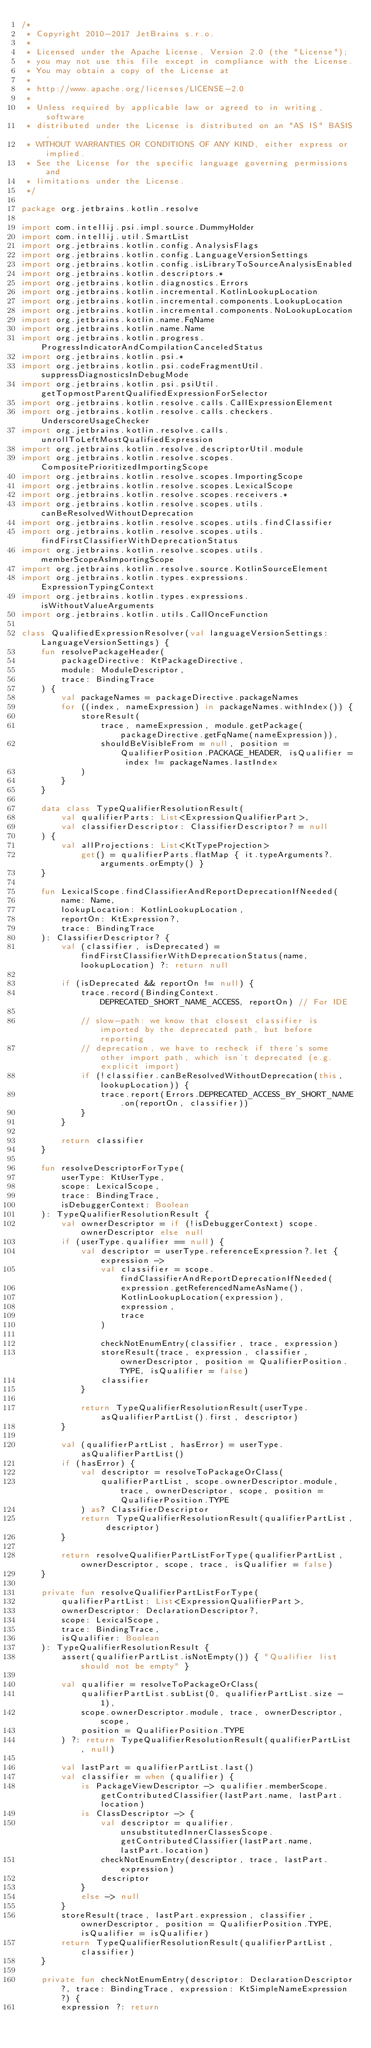<code> <loc_0><loc_0><loc_500><loc_500><_Kotlin_>/*
 * Copyright 2010-2017 JetBrains s.r.o.
 *
 * Licensed under the Apache License, Version 2.0 (the "License");
 * you may not use this file except in compliance with the License.
 * You may obtain a copy of the License at
 *
 * http://www.apache.org/licenses/LICENSE-2.0
 *
 * Unless required by applicable law or agreed to in writing, software
 * distributed under the License is distributed on an "AS IS" BASIS,
 * WITHOUT WARRANTIES OR CONDITIONS OF ANY KIND, either express or implied.
 * See the License for the specific language governing permissions and
 * limitations under the License.
 */

package org.jetbrains.kotlin.resolve

import com.intellij.psi.impl.source.DummyHolder
import com.intellij.util.SmartList
import org.jetbrains.kotlin.config.AnalysisFlags
import org.jetbrains.kotlin.config.LanguageVersionSettings
import org.jetbrains.kotlin.config.isLibraryToSourceAnalysisEnabled
import org.jetbrains.kotlin.descriptors.*
import org.jetbrains.kotlin.diagnostics.Errors
import org.jetbrains.kotlin.incremental.KotlinLookupLocation
import org.jetbrains.kotlin.incremental.components.LookupLocation
import org.jetbrains.kotlin.incremental.components.NoLookupLocation
import org.jetbrains.kotlin.name.FqName
import org.jetbrains.kotlin.name.Name
import org.jetbrains.kotlin.progress.ProgressIndicatorAndCompilationCanceledStatus
import org.jetbrains.kotlin.psi.*
import org.jetbrains.kotlin.psi.codeFragmentUtil.suppressDiagnosticsInDebugMode
import org.jetbrains.kotlin.psi.psiUtil.getTopmostParentQualifiedExpressionForSelector
import org.jetbrains.kotlin.resolve.calls.CallExpressionElement
import org.jetbrains.kotlin.resolve.calls.checkers.UnderscoreUsageChecker
import org.jetbrains.kotlin.resolve.calls.unrollToLeftMostQualifiedExpression
import org.jetbrains.kotlin.resolve.descriptorUtil.module
import org.jetbrains.kotlin.resolve.scopes.CompositePrioritizedImportingScope
import org.jetbrains.kotlin.resolve.scopes.ImportingScope
import org.jetbrains.kotlin.resolve.scopes.LexicalScope
import org.jetbrains.kotlin.resolve.scopes.receivers.*
import org.jetbrains.kotlin.resolve.scopes.utils.canBeResolvedWithoutDeprecation
import org.jetbrains.kotlin.resolve.scopes.utils.findClassifier
import org.jetbrains.kotlin.resolve.scopes.utils.findFirstClassifierWithDeprecationStatus
import org.jetbrains.kotlin.resolve.scopes.utils.memberScopeAsImportingScope
import org.jetbrains.kotlin.resolve.source.KotlinSourceElement
import org.jetbrains.kotlin.types.expressions.ExpressionTypingContext
import org.jetbrains.kotlin.types.expressions.isWithoutValueArguments
import org.jetbrains.kotlin.utils.CallOnceFunction

class QualifiedExpressionResolver(val languageVersionSettings: LanguageVersionSettings) {
    fun resolvePackageHeader(
        packageDirective: KtPackageDirective,
        module: ModuleDescriptor,
        trace: BindingTrace
    ) {
        val packageNames = packageDirective.packageNames
        for ((index, nameExpression) in packageNames.withIndex()) {
            storeResult(
                trace, nameExpression, module.getPackage(packageDirective.getFqName(nameExpression)),
                shouldBeVisibleFrom = null, position = QualifierPosition.PACKAGE_HEADER, isQualifier = index != packageNames.lastIndex
            )
        }
    }

    data class TypeQualifierResolutionResult(
        val qualifierParts: List<ExpressionQualifierPart>,
        val classifierDescriptor: ClassifierDescriptor? = null
    ) {
        val allProjections: List<KtTypeProjection>
            get() = qualifierParts.flatMap { it.typeArguments?.arguments.orEmpty() }
    }

    fun LexicalScope.findClassifierAndReportDeprecationIfNeeded(
        name: Name,
        lookupLocation: KotlinLookupLocation,
        reportOn: KtExpression?,
        trace: BindingTrace
    ): ClassifierDescriptor? {
        val (classifier, isDeprecated) = findFirstClassifierWithDeprecationStatus(name, lookupLocation) ?: return null

        if (isDeprecated && reportOn != null) {
            trace.record(BindingContext.DEPRECATED_SHORT_NAME_ACCESS, reportOn) // For IDE

            // slow-path: we know that closest classifier is imported by the deprecated path, but before reporting
            // deprecation, we have to recheck if there's some other import path, which isn't deprecated (e.g. explicit import)
            if (!classifier.canBeResolvedWithoutDeprecation(this, lookupLocation)) {
                trace.report(Errors.DEPRECATED_ACCESS_BY_SHORT_NAME.on(reportOn, classifier))
            }
        }

        return classifier
    }

    fun resolveDescriptorForType(
        userType: KtUserType,
        scope: LexicalScope,
        trace: BindingTrace,
        isDebuggerContext: Boolean
    ): TypeQualifierResolutionResult {
        val ownerDescriptor = if (!isDebuggerContext) scope.ownerDescriptor else null
        if (userType.qualifier == null) {
            val descriptor = userType.referenceExpression?.let { expression ->
                val classifier = scope.findClassifierAndReportDeprecationIfNeeded(
                    expression.getReferencedNameAsName(),
                    KotlinLookupLocation(expression),
                    expression,
                    trace
                )

                checkNotEnumEntry(classifier, trace, expression)
                storeResult(trace, expression, classifier, ownerDescriptor, position = QualifierPosition.TYPE, isQualifier = false)
                classifier
            }

            return TypeQualifierResolutionResult(userType.asQualifierPartList().first, descriptor)
        }

        val (qualifierPartList, hasError) = userType.asQualifierPartList()
        if (hasError) {
            val descriptor = resolveToPackageOrClass(
                qualifierPartList, scope.ownerDescriptor.module, trace, ownerDescriptor, scope, position = QualifierPosition.TYPE
            ) as? ClassifierDescriptor
            return TypeQualifierResolutionResult(qualifierPartList, descriptor)
        }

        return resolveQualifierPartListForType(qualifierPartList, ownerDescriptor, scope, trace, isQualifier = false)
    }

    private fun resolveQualifierPartListForType(
        qualifierPartList: List<ExpressionQualifierPart>,
        ownerDescriptor: DeclarationDescriptor?,
        scope: LexicalScope,
        trace: BindingTrace,
        isQualifier: Boolean
    ): TypeQualifierResolutionResult {
        assert(qualifierPartList.isNotEmpty()) { "Qualifier list should not be empty" }

        val qualifier = resolveToPackageOrClass(
            qualifierPartList.subList(0, qualifierPartList.size - 1),
            scope.ownerDescriptor.module, trace, ownerDescriptor, scope,
            position = QualifierPosition.TYPE
        ) ?: return TypeQualifierResolutionResult(qualifierPartList, null)

        val lastPart = qualifierPartList.last()
        val classifier = when (qualifier) {
            is PackageViewDescriptor -> qualifier.memberScope.getContributedClassifier(lastPart.name, lastPart.location)
            is ClassDescriptor -> {
                val descriptor = qualifier.unsubstitutedInnerClassesScope.getContributedClassifier(lastPart.name, lastPart.location)
                checkNotEnumEntry(descriptor, trace, lastPart.expression)
                descriptor
            }
            else -> null
        }
        storeResult(trace, lastPart.expression, classifier, ownerDescriptor, position = QualifierPosition.TYPE, isQualifier = isQualifier)
        return TypeQualifierResolutionResult(qualifierPartList, classifier)
    }

    private fun checkNotEnumEntry(descriptor: DeclarationDescriptor?, trace: BindingTrace, expression: KtSimpleNameExpression?) {
        expression ?: return</code> 